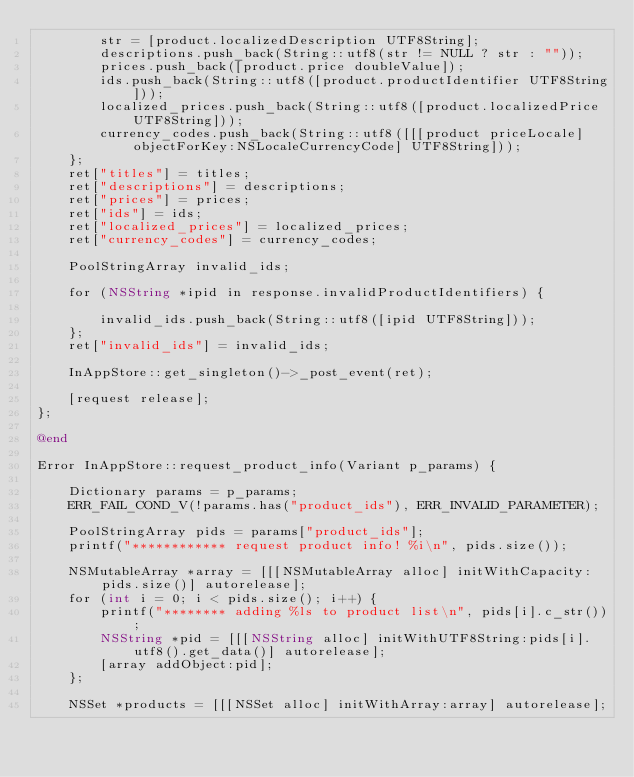Convert code to text. <code><loc_0><loc_0><loc_500><loc_500><_ObjectiveC_>		str = [product.localizedDescription UTF8String];
		descriptions.push_back(String::utf8(str != NULL ? str : ""));
		prices.push_back([product.price doubleValue]);
		ids.push_back(String::utf8([product.productIdentifier UTF8String]));
		localized_prices.push_back(String::utf8([product.localizedPrice UTF8String]));
		currency_codes.push_back(String::utf8([[[product priceLocale] objectForKey:NSLocaleCurrencyCode] UTF8String]));
	};
	ret["titles"] = titles;
	ret["descriptions"] = descriptions;
	ret["prices"] = prices;
	ret["ids"] = ids;
	ret["localized_prices"] = localized_prices;
	ret["currency_codes"] = currency_codes;

	PoolStringArray invalid_ids;

	for (NSString *ipid in response.invalidProductIdentifiers) {

		invalid_ids.push_back(String::utf8([ipid UTF8String]));
	};
	ret["invalid_ids"] = invalid_ids;

	InAppStore::get_singleton()->_post_event(ret);

	[request release];
};

@end

Error InAppStore::request_product_info(Variant p_params) {

	Dictionary params = p_params;
	ERR_FAIL_COND_V(!params.has("product_ids"), ERR_INVALID_PARAMETER);

	PoolStringArray pids = params["product_ids"];
	printf("************ request product info! %i\n", pids.size());

	NSMutableArray *array = [[[NSMutableArray alloc] initWithCapacity:pids.size()] autorelease];
	for (int i = 0; i < pids.size(); i++) {
		printf("******** adding %ls to product list\n", pids[i].c_str());
		NSString *pid = [[[NSString alloc] initWithUTF8String:pids[i].utf8().get_data()] autorelease];
		[array addObject:pid];
	};

	NSSet *products = [[[NSSet alloc] initWithArray:array] autorelease];</code> 